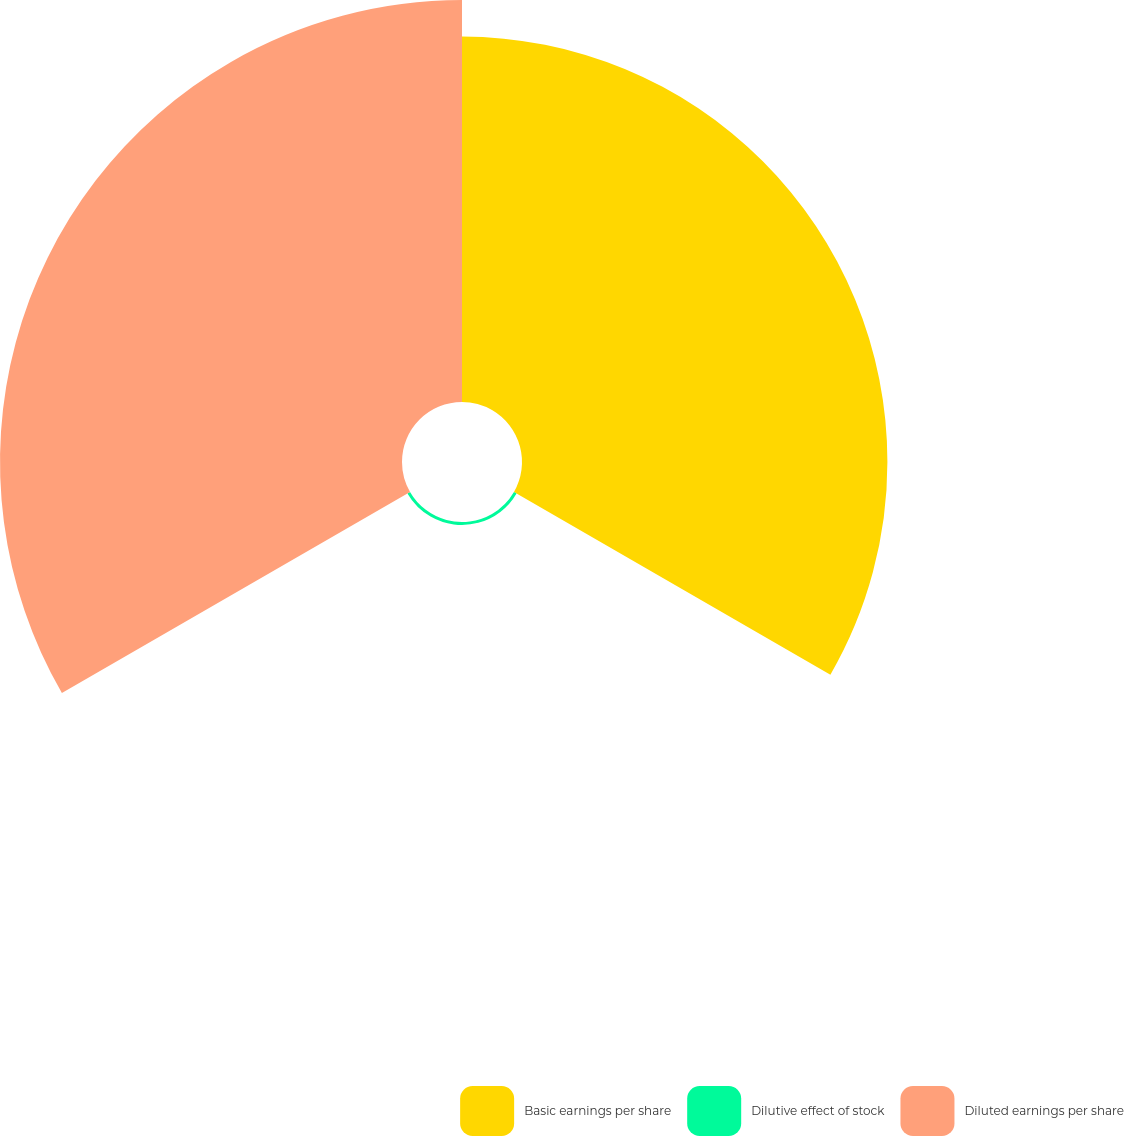<chart> <loc_0><loc_0><loc_500><loc_500><pie_chart><fcel>Basic earnings per share<fcel>Dilutive effect of stock<fcel>Diluted earnings per share<nl><fcel>47.43%<fcel>0.39%<fcel>52.18%<nl></chart> 